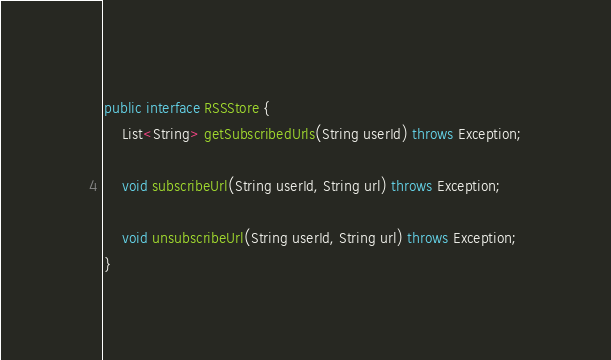<code> <loc_0><loc_0><loc_500><loc_500><_Java_>public interface RSSStore {
    List<String> getSubscribedUrls(String userId) throws Exception;

    void subscribeUrl(String userId, String url) throws Exception;

    void unsubscribeUrl(String userId, String url) throws Exception;
}</code> 